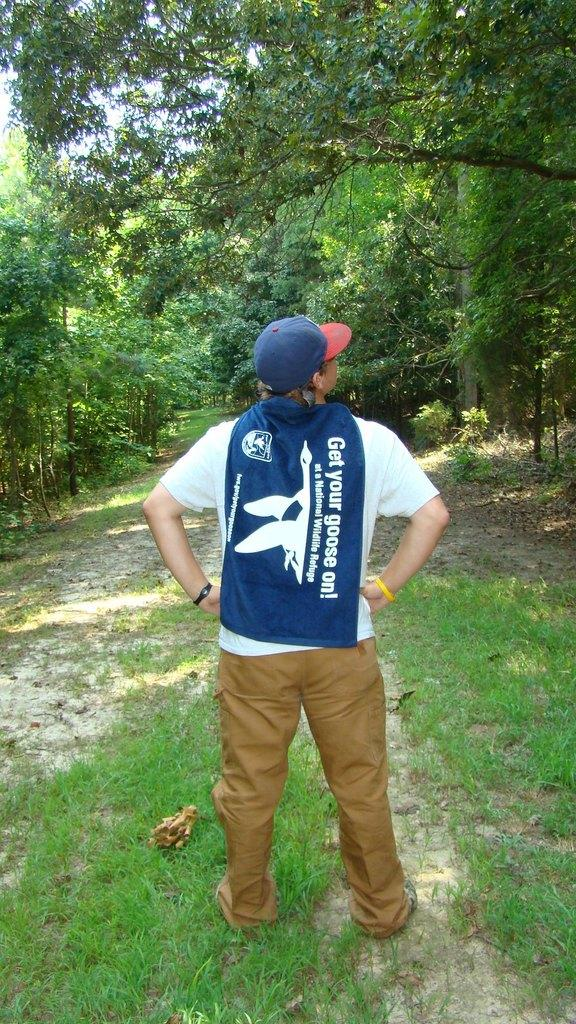<image>
Render a clear and concise summary of the photo. a man wearing a blue cape that says 'get your goose on' 